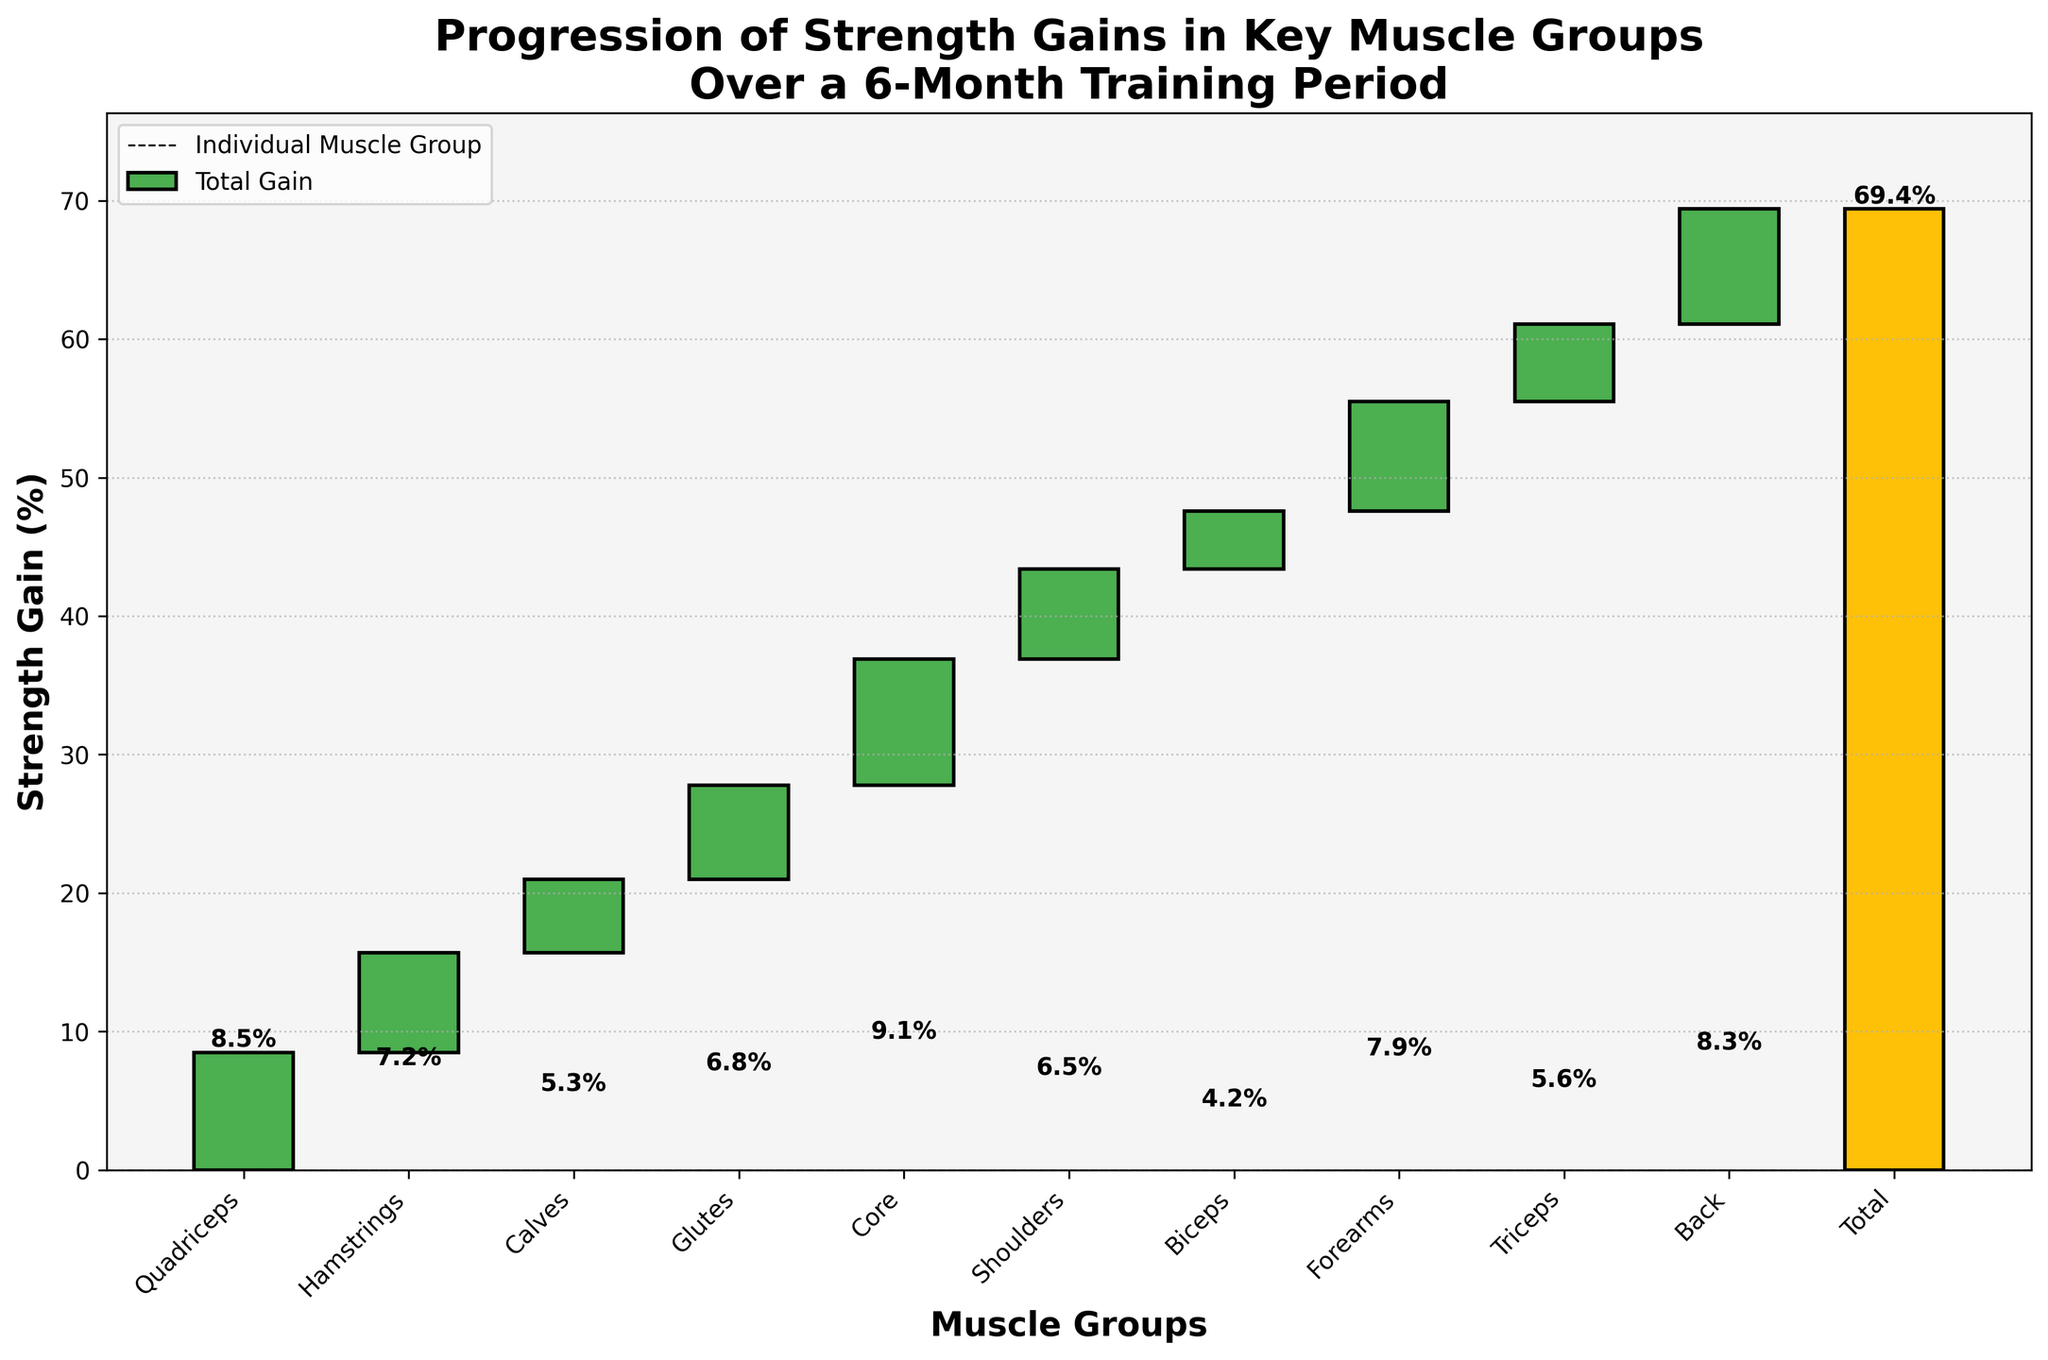What's the title of the figure? The title is located at the top of the figure and gives a summary of what the chart is about. It reads, "Progression of Strength Gains in Key Muscle Groups Over a 6-Month Training Period".
Answer: Progression of Strength Gains in Key Muscle Groups Over a 6-Month Training Period How many muscle groups are displayed in the chart? Count the muscle groups listed on the x-axis, excluding the "Total" bar. There are eight muscle groups.
Answer: 10 Which muscle group shows the highest strength gain? By looking at the height of the bars, the "Core" muscle group has the highest strength gain, with a value of 9.1%.
Answer: Core What is the total percentage of strength gain over the 6-month period? The last bar represents the total strength gain, which is annotated above the bar. This value is 69.4%.
Answer: 69.4% Which muscle group shows the lowest strength gain? By comparing the heights of all the muscle groups' bars, the "Biceps" muscle group has the lowest strength gain at 4.2%.
Answer: Biceps What's the difference in strength gain between the Core and the Calves muscle groups? The Core muscle group has a gain of 9.1%, and the Calves have a gain of 5.3%. The difference is 9.1% - 5.3% = 3.8%.
Answer: 3.8% How does the strength gain of the Glutes compare to that of the Hamstrings? The Glutes have a strength gain of 6.8%, while the Hamstrings have 7.2%. Thus, the Glutes have a lower gain by 0.4%.
Answer: Glutes are 0.4% lower What is the combined strength gain percentage of the Quadriceps and Shoulders? Add the gains of Quadriceps (8.5%) and Shoulders (6.5%), which gives 8.5% + 6.5% = 15%.
Answer: 15% If you consider only the percentage gains of the shouldes, triceps, and forearms, what's their average? Add the gains of Shoulders (6.5%), Triceps (5.6%), and Forearms (7.9%), and divide by 3. The calculation is (6.5 + 5.6 + 7.9) / 3 = 20 / 3 = 6.67%.
Answer: 6.67% What percentage increase in strength gains do the shoulders contribute to the total gain? The strength gain for the Shoulders is 6.5%. The total strength gain over the period is 69.4%. The percentage contribution is (6.5 / 69.4) * 100 ≈ 9.36%.
Answer: 9.36% 